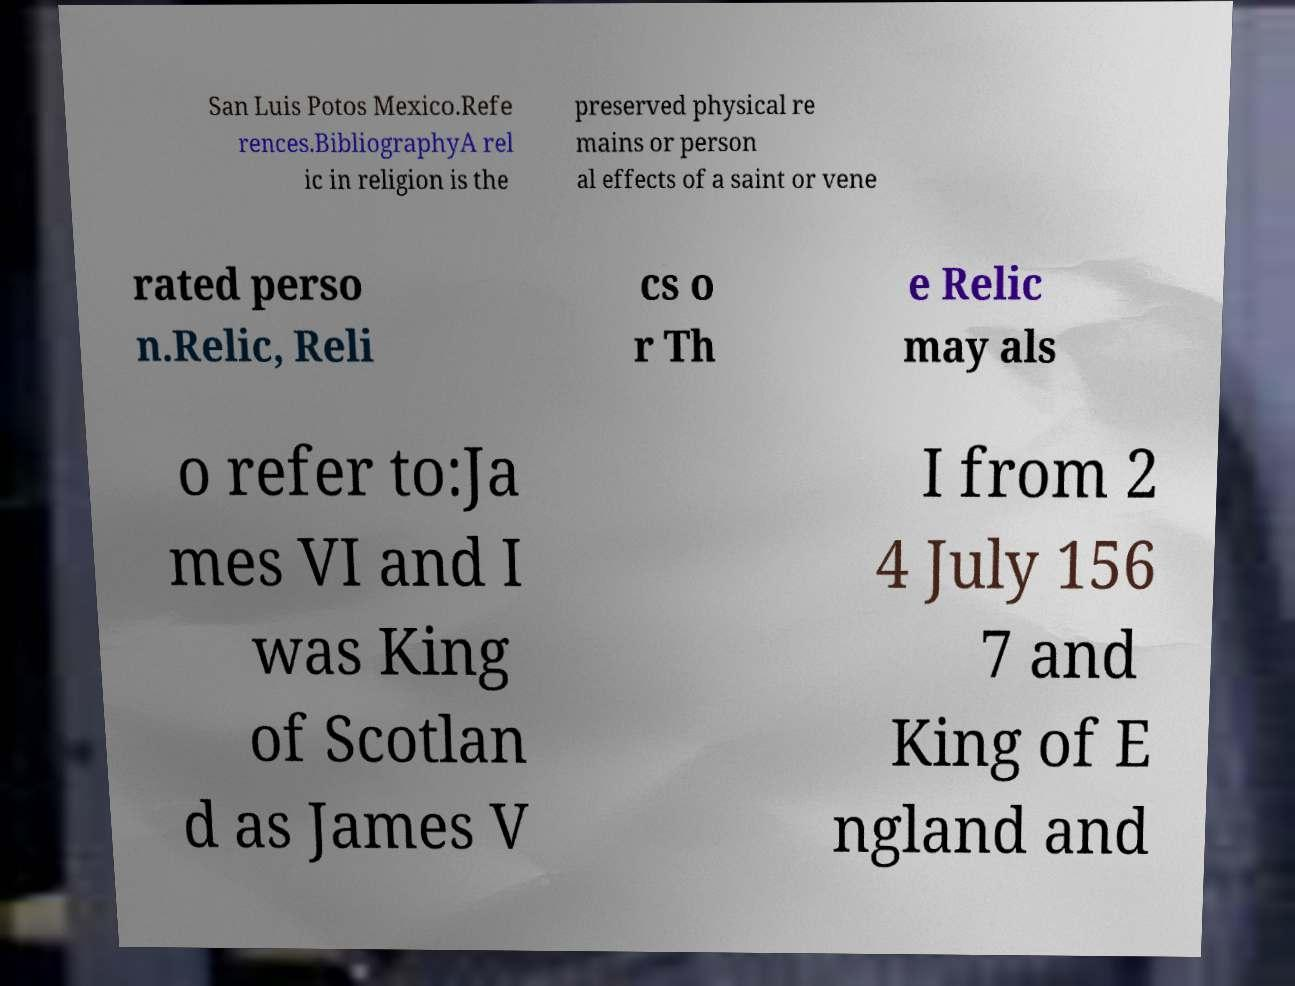For documentation purposes, I need the text within this image transcribed. Could you provide that? San Luis Potos Mexico.Refe rences.BibliographyA rel ic in religion is the preserved physical re mains or person al effects of a saint or vene rated perso n.Relic, Reli cs o r Th e Relic may als o refer to:Ja mes VI and I was King of Scotlan d as James V I from 2 4 July 156 7 and King of E ngland and 